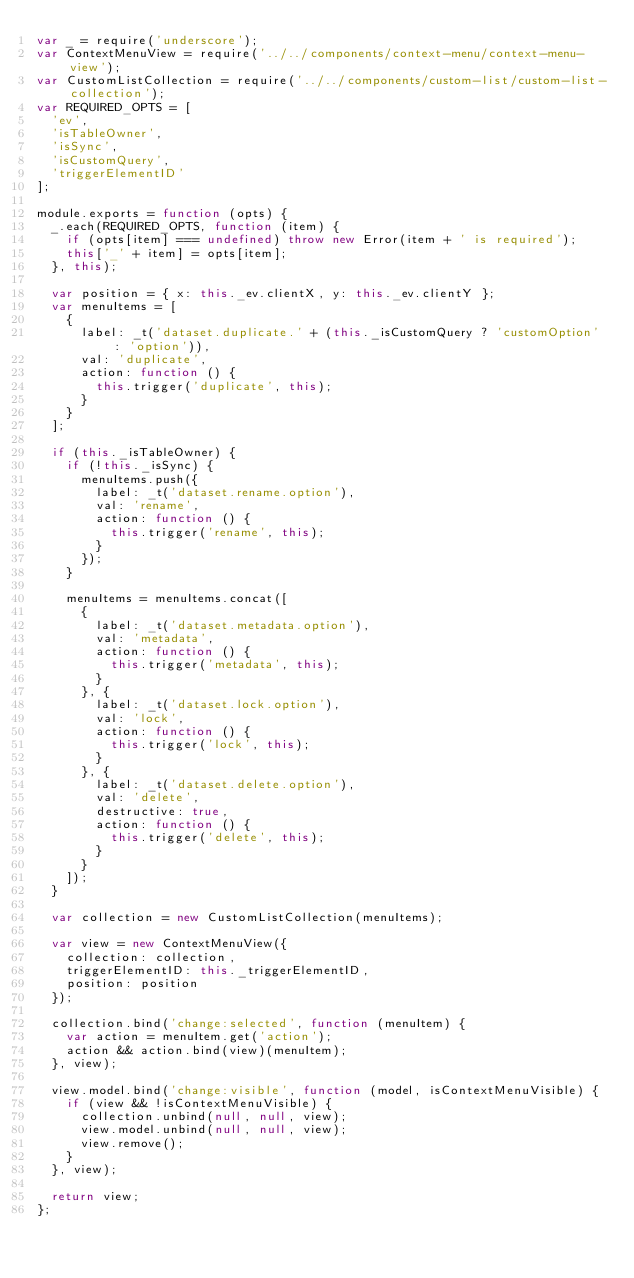Convert code to text. <code><loc_0><loc_0><loc_500><loc_500><_JavaScript_>var _ = require('underscore');
var ContextMenuView = require('../../components/context-menu/context-menu-view');
var CustomListCollection = require('../../components/custom-list/custom-list-collection');
var REQUIRED_OPTS = [
  'ev',
  'isTableOwner',
  'isSync',
  'isCustomQuery',
  'triggerElementID'
];

module.exports = function (opts) {
  _.each(REQUIRED_OPTS, function (item) {
    if (opts[item] === undefined) throw new Error(item + ' is required');
    this['_' + item] = opts[item];
  }, this);

  var position = { x: this._ev.clientX, y: this._ev.clientY };
  var menuItems = [
    {
      label: _t('dataset.duplicate.' + (this._isCustomQuery ? 'customOption' : 'option')),
      val: 'duplicate',
      action: function () {
        this.trigger('duplicate', this);
      }
    }
  ];

  if (this._isTableOwner) {
    if (!this._isSync) {
      menuItems.push({
        label: _t('dataset.rename.option'),
        val: 'rename',
        action: function () {
          this.trigger('rename', this);
        }
      });
    }

    menuItems = menuItems.concat([
      {
        label: _t('dataset.metadata.option'),
        val: 'metadata',
        action: function () {
          this.trigger('metadata', this);
        }
      }, {
        label: _t('dataset.lock.option'),
        val: 'lock',
        action: function () {
          this.trigger('lock', this);
        }
      }, {
        label: _t('dataset.delete.option'),
        val: 'delete',
        destructive: true,
        action: function () {
          this.trigger('delete', this);
        }
      }
    ]);
  }

  var collection = new CustomListCollection(menuItems);

  var view = new ContextMenuView({
    collection: collection,
    triggerElementID: this._triggerElementID,
    position: position
  });

  collection.bind('change:selected', function (menuItem) {
    var action = menuItem.get('action');
    action && action.bind(view)(menuItem);
  }, view);

  view.model.bind('change:visible', function (model, isContextMenuVisible) {
    if (view && !isContextMenuVisible) {
      collection.unbind(null, null, view);
      view.model.unbind(null, null, view);
      view.remove();
    }
  }, view);

  return view;
};
</code> 